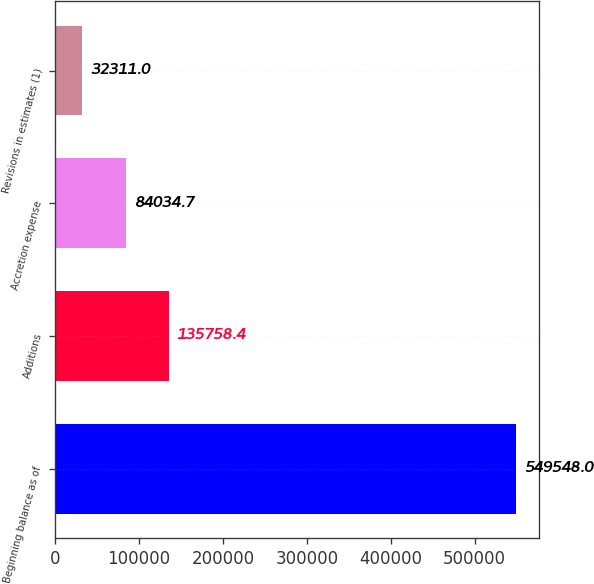<chart> <loc_0><loc_0><loc_500><loc_500><bar_chart><fcel>Beginning balance as of<fcel>Additions<fcel>Accretion expense<fcel>Revisions in estimates (1)<nl><fcel>549548<fcel>135758<fcel>84034.7<fcel>32311<nl></chart> 